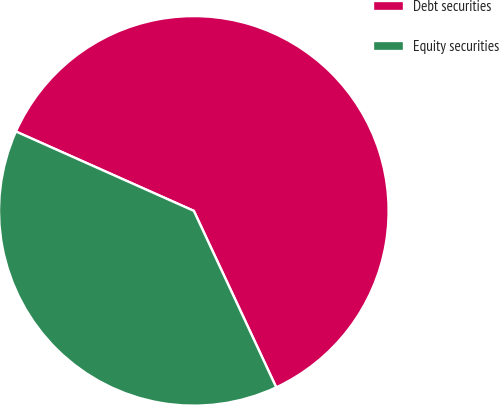<chart> <loc_0><loc_0><loc_500><loc_500><pie_chart><fcel>Debt securities<fcel>Equity securities<nl><fcel>61.37%<fcel>38.63%<nl></chart> 